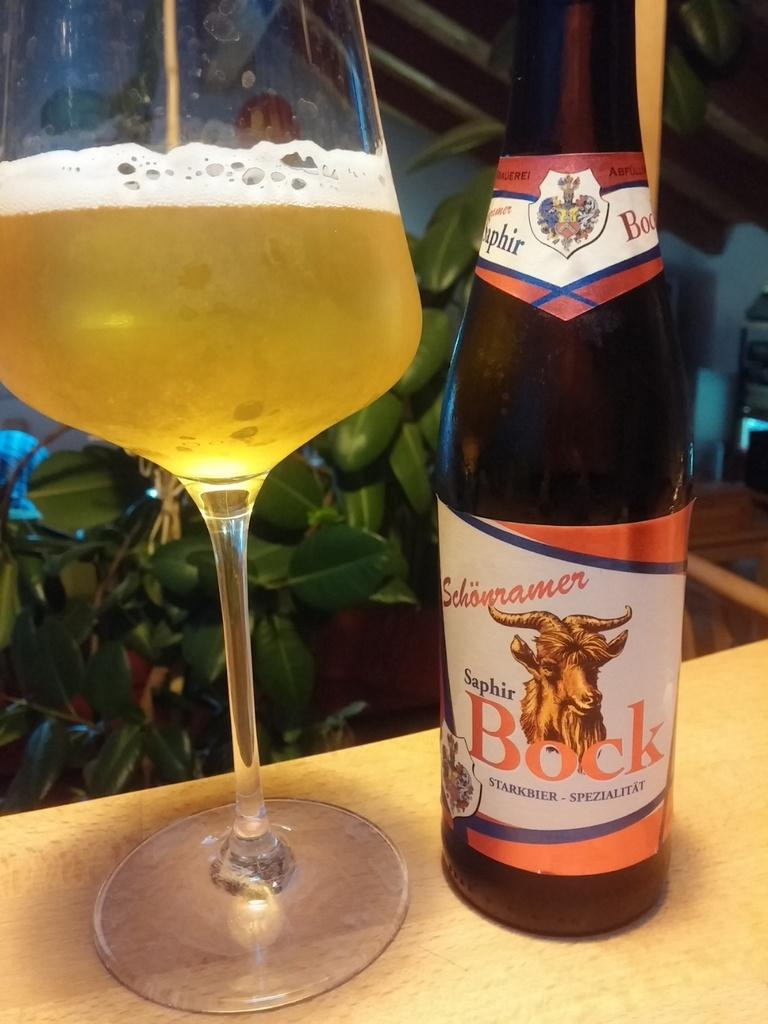<image>
Provide a brief description of the given image. Schonramer Saphir Bock alcohol bottle next to a half-filled wine glass. 